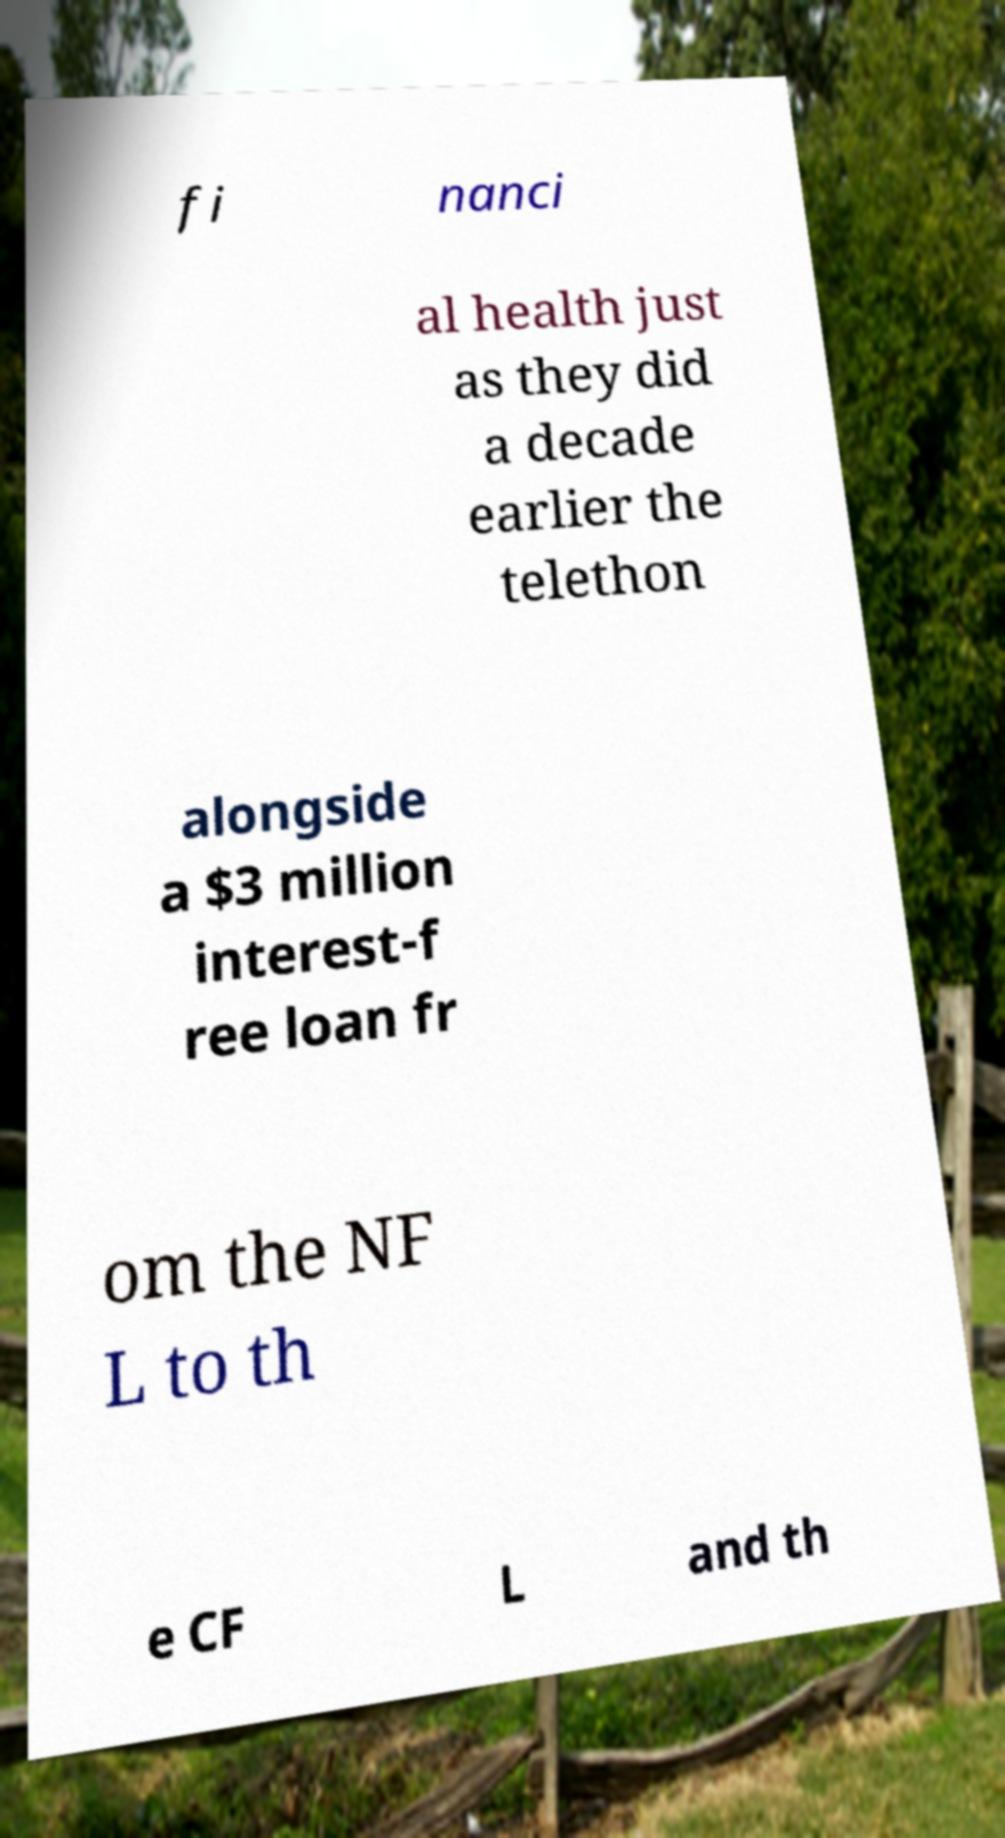Please read and relay the text visible in this image. What does it say? fi nanci al health just as they did a decade earlier the telethon alongside a $3 million interest-f ree loan fr om the NF L to th e CF L and th 